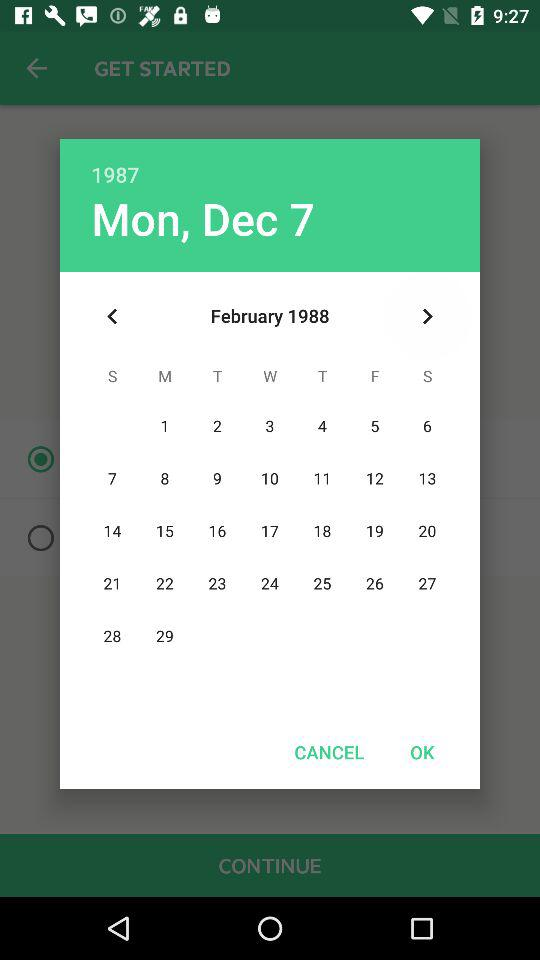What is the selected date? The selected date is Monday, December 7, 1987. 